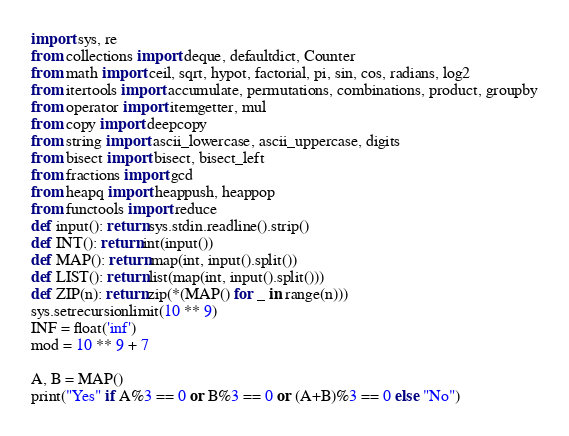<code> <loc_0><loc_0><loc_500><loc_500><_Python_>import sys, re
from collections import deque, defaultdict, Counter
from math import ceil, sqrt, hypot, factorial, pi, sin, cos, radians, log2
from itertools import accumulate, permutations, combinations, product, groupby
from operator import itemgetter, mul
from copy import deepcopy
from string import ascii_lowercase, ascii_uppercase, digits
from bisect import bisect, bisect_left
from fractions import gcd
from heapq import heappush, heappop
from functools import reduce
def input(): return sys.stdin.readline().strip()
def INT(): return int(input())
def MAP(): return map(int, input().split())
def LIST(): return list(map(int, input().split()))
def ZIP(n): return zip(*(MAP() for _ in range(n)))
sys.setrecursionlimit(10 ** 9)
INF = float('inf')
mod = 10 ** 9 + 7
 
A, B = MAP()
print("Yes" if A%3 == 0 or B%3 == 0 or (A+B)%3 == 0 else "No")</code> 